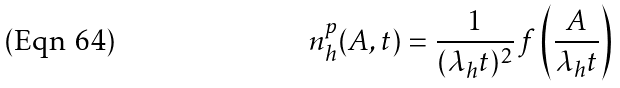Convert formula to latex. <formula><loc_0><loc_0><loc_500><loc_500>n ^ { p } _ { h } ( A , t ) = \frac { 1 } { ( \lambda _ { h } t ) ^ { 2 } } \, f \left ( \frac { A } { \lambda _ { h } t } \right )</formula> 